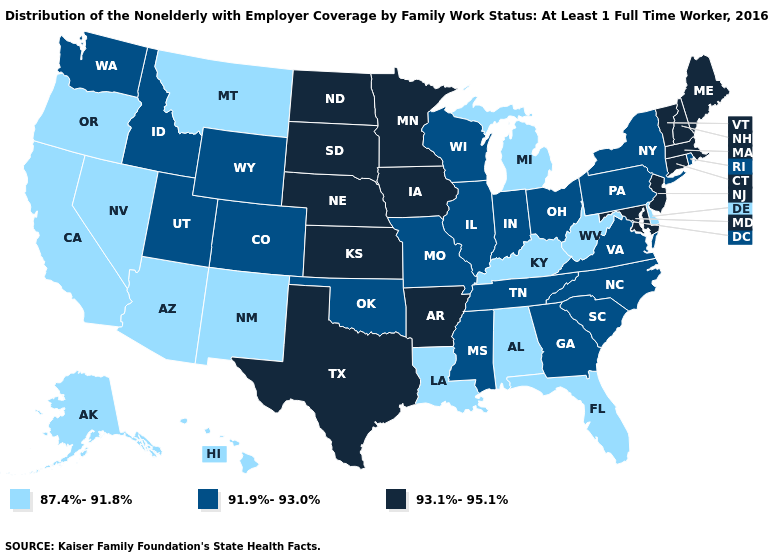How many symbols are there in the legend?
Answer briefly. 3. Name the states that have a value in the range 87.4%-91.8%?
Keep it brief. Alabama, Alaska, Arizona, California, Delaware, Florida, Hawaii, Kentucky, Louisiana, Michigan, Montana, Nevada, New Mexico, Oregon, West Virginia. Does the map have missing data?
Be succinct. No. Name the states that have a value in the range 91.9%-93.0%?
Answer briefly. Colorado, Georgia, Idaho, Illinois, Indiana, Mississippi, Missouri, New York, North Carolina, Ohio, Oklahoma, Pennsylvania, Rhode Island, South Carolina, Tennessee, Utah, Virginia, Washington, Wisconsin, Wyoming. Name the states that have a value in the range 93.1%-95.1%?
Write a very short answer. Arkansas, Connecticut, Iowa, Kansas, Maine, Maryland, Massachusetts, Minnesota, Nebraska, New Hampshire, New Jersey, North Dakota, South Dakota, Texas, Vermont. Does California have the same value as Washington?
Short answer required. No. Does Ohio have a higher value than Louisiana?
Quick response, please. Yes. How many symbols are there in the legend?
Give a very brief answer. 3. Which states hav the highest value in the West?
Concise answer only. Colorado, Idaho, Utah, Washington, Wyoming. Name the states that have a value in the range 87.4%-91.8%?
Give a very brief answer. Alabama, Alaska, Arizona, California, Delaware, Florida, Hawaii, Kentucky, Louisiana, Michigan, Montana, Nevada, New Mexico, Oregon, West Virginia. Does Montana have the same value as Iowa?
Be succinct. No. Which states have the lowest value in the West?
Write a very short answer. Alaska, Arizona, California, Hawaii, Montana, Nevada, New Mexico, Oregon. Does Vermont have the same value as South Dakota?
Quick response, please. Yes. Which states hav the highest value in the West?
Short answer required. Colorado, Idaho, Utah, Washington, Wyoming. Among the states that border Georgia , which have the lowest value?
Concise answer only. Alabama, Florida. 